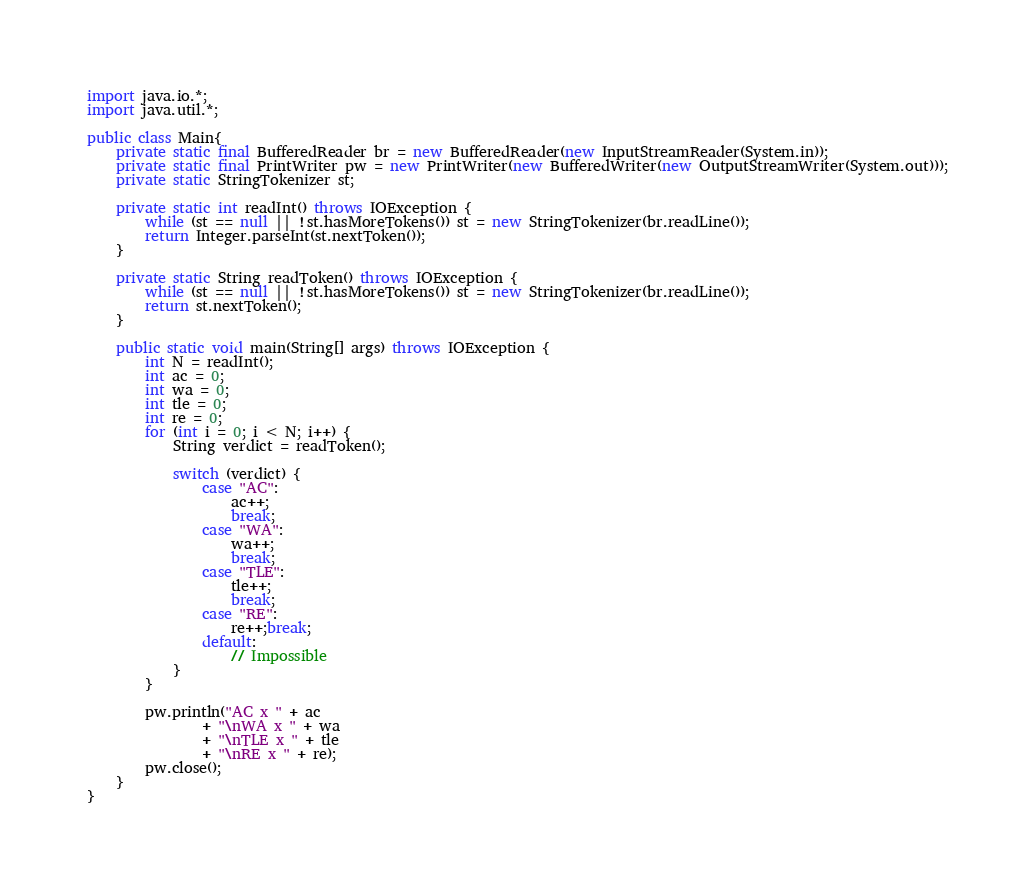Convert code to text. <code><loc_0><loc_0><loc_500><loc_500><_Java_>import java.io.*;
import java.util.*;

public class Main{
    private static final BufferedReader br = new BufferedReader(new InputStreamReader(System.in));
    private static final PrintWriter pw = new PrintWriter(new BufferedWriter(new OutputStreamWriter(System.out)));
    private static StringTokenizer st;

    private static int readInt() throws IOException {
        while (st == null || !st.hasMoreTokens()) st = new StringTokenizer(br.readLine());
        return Integer.parseInt(st.nextToken());
    }

    private static String readToken() throws IOException {
        while (st == null || !st.hasMoreTokens()) st = new StringTokenizer(br.readLine());
        return st.nextToken();
    }

    public static void main(String[] args) throws IOException {
        int N = readInt();
        int ac = 0;
        int wa = 0;
        int tle = 0;
        int re = 0;
        for (int i = 0; i < N; i++) {
            String verdict = readToken();

            switch (verdict) {
                case "AC":
                    ac++;
                    break;
                case "WA":
                    wa++;
                    break;
                case "TLE":
                    tle++;
                    break;
                case "RE":
                    re++;break;
                default:
                    // Impossible
            }
        }

        pw.println("AC x " + ac
                + "\nWA x " + wa
                + "\nTLE x " + tle
                + "\nRE x " + re);
        pw.close();
    }
}
</code> 